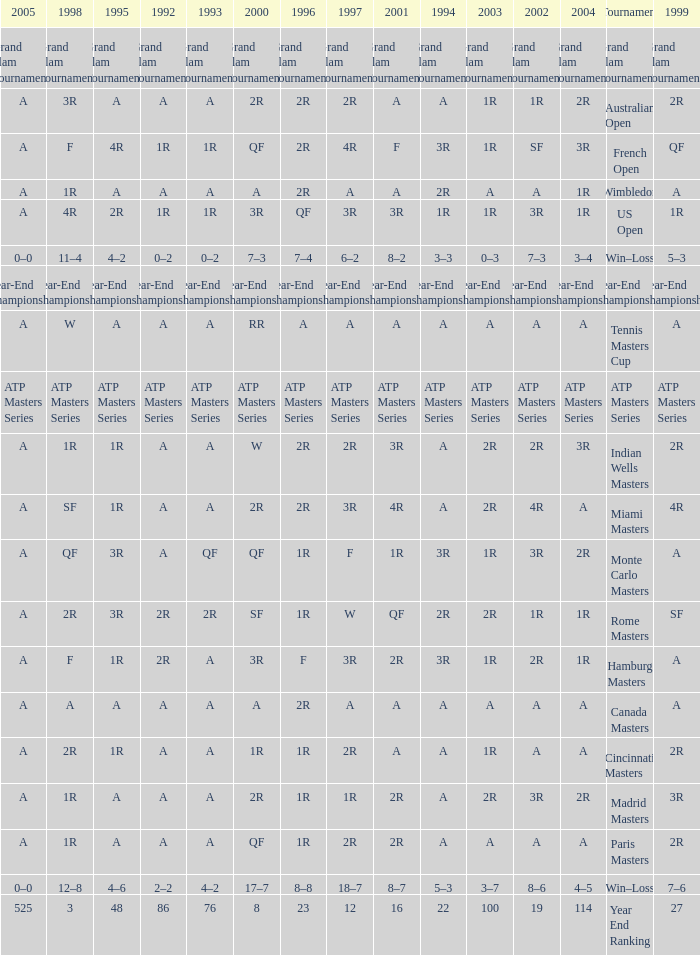What is Tournament, when 2000 is "A"? Wimbledon, Canada Masters. 